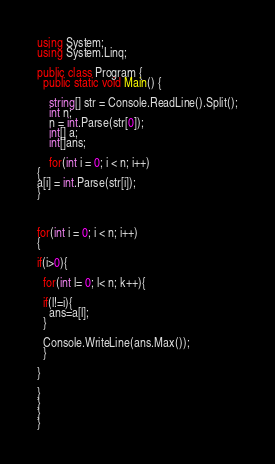<code> <loc_0><loc_0><loc_500><loc_500><_C#_>using System;
using System.Linq;

public class Program {
  public static void Main() {
    
    string[] str = Console.ReadLine().Split();
    int n;
    n = int.Parse(str[0]);
    int[] a;
    int[]ans;
    
    for(int i = 0; i < n; i++)
{
a[i] = int.Parse(str[i]);
}



for(int i = 0; i < n; i++)
{

if(i>0){
  
  for(int l= 0; l< n; k++){
    
  if(l!=i){
    ans=a[l];
  }
  
  Console.WriteLine(ans.Max());
  }
  
}

}
}
}
}</code> 